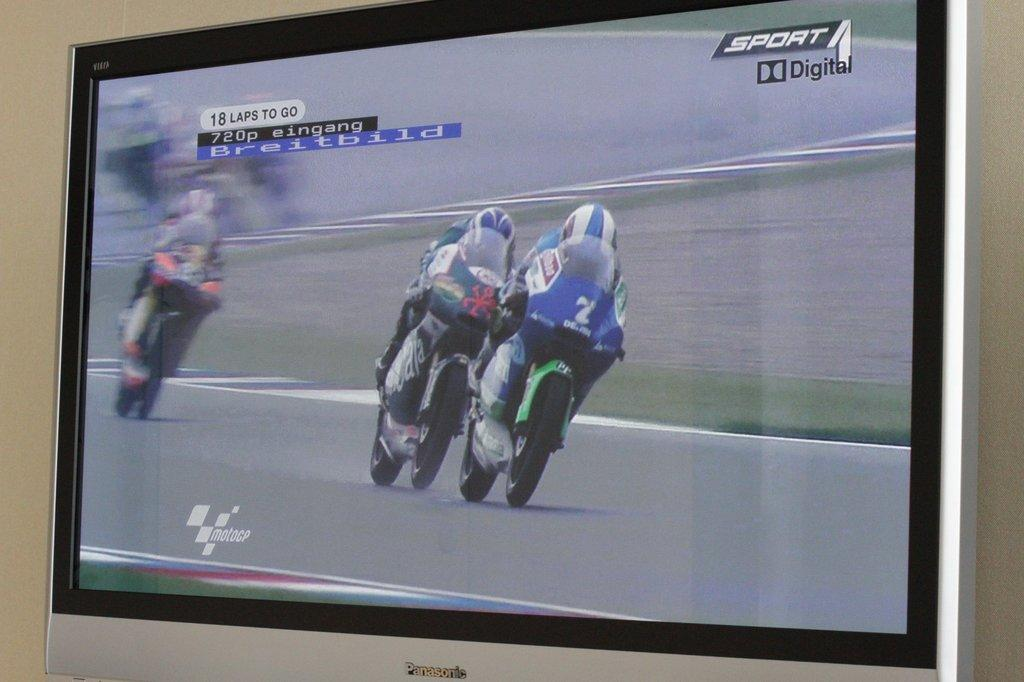<image>
Present a compact description of the photo's key features. Three motorcycle racers in a race with 18 laps to go. 